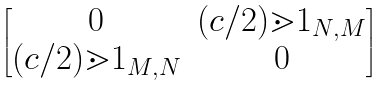Convert formula to latex. <formula><loc_0><loc_0><loc_500><loc_500>\begin{bmatrix} 0 & ( c / 2 ) \mathbb { m } { 1 } _ { N , M } \\ ( c / 2 ) \mathbb { m } { 1 } _ { M , N } & 0 \end{bmatrix}</formula> 